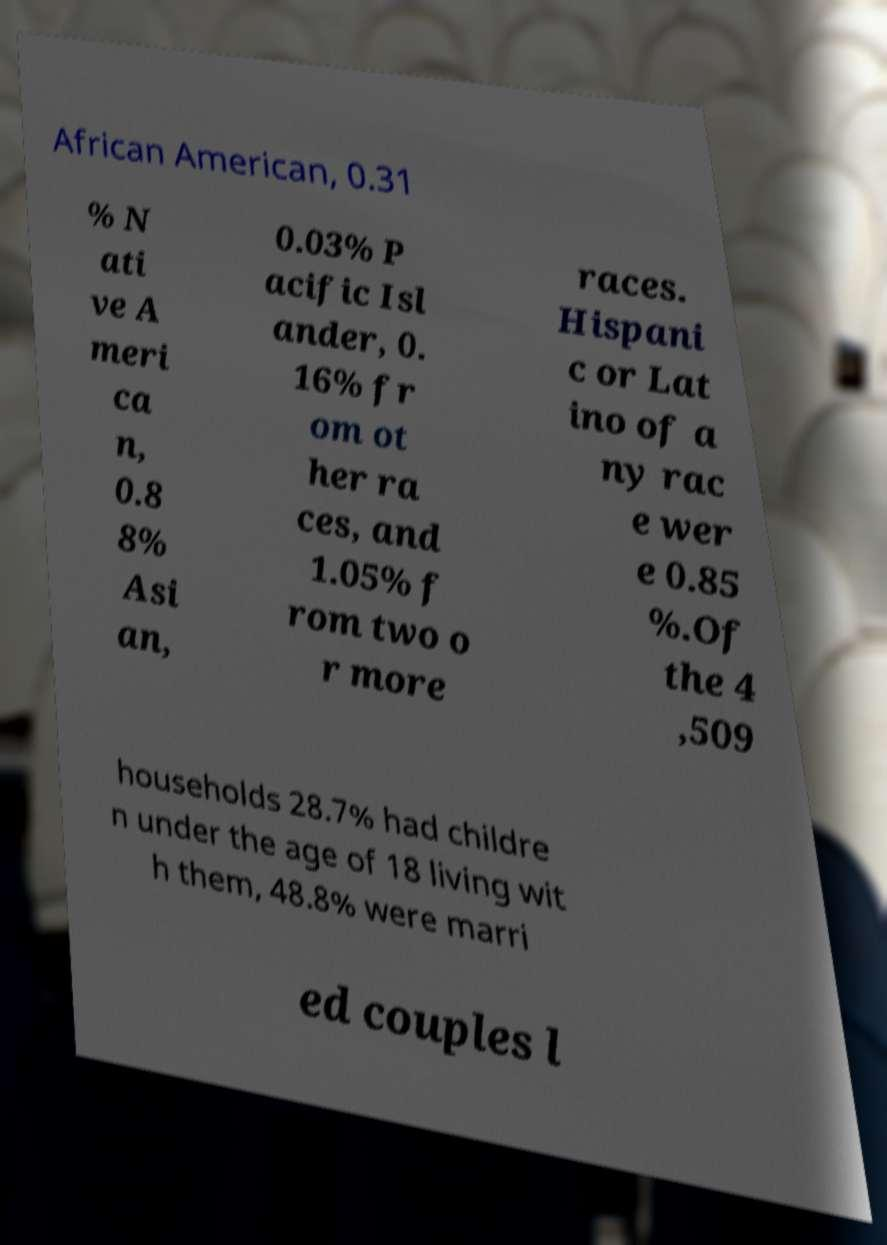Could you assist in decoding the text presented in this image and type it out clearly? African American, 0.31 % N ati ve A meri ca n, 0.8 8% Asi an, 0.03% P acific Isl ander, 0. 16% fr om ot her ra ces, and 1.05% f rom two o r more races. Hispani c or Lat ino of a ny rac e wer e 0.85 %.Of the 4 ,509 households 28.7% had childre n under the age of 18 living wit h them, 48.8% were marri ed couples l 